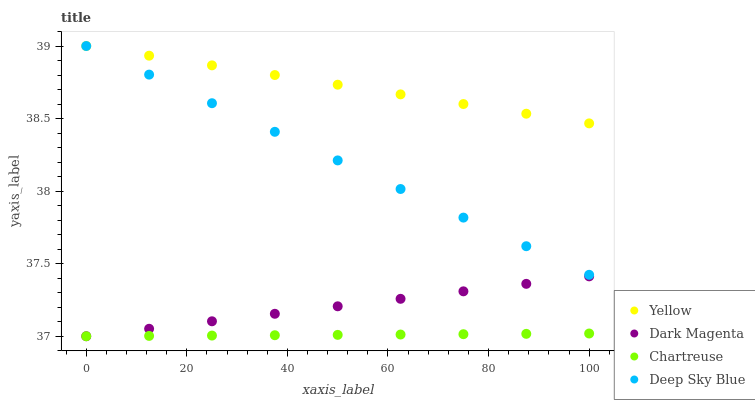Does Chartreuse have the minimum area under the curve?
Answer yes or no. Yes. Does Yellow have the maximum area under the curve?
Answer yes or no. Yes. Does Dark Magenta have the minimum area under the curve?
Answer yes or no. No. Does Dark Magenta have the maximum area under the curve?
Answer yes or no. No. Is Dark Magenta the smoothest?
Answer yes or no. Yes. Is Yellow the roughest?
Answer yes or no. Yes. Is Chartreuse the smoothest?
Answer yes or no. No. Is Chartreuse the roughest?
Answer yes or no. No. Does Chartreuse have the lowest value?
Answer yes or no. Yes. Does Yellow have the lowest value?
Answer yes or no. No. Does Yellow have the highest value?
Answer yes or no. Yes. Does Dark Magenta have the highest value?
Answer yes or no. No. Is Chartreuse less than Deep Sky Blue?
Answer yes or no. Yes. Is Deep Sky Blue greater than Dark Magenta?
Answer yes or no. Yes. Does Yellow intersect Deep Sky Blue?
Answer yes or no. Yes. Is Yellow less than Deep Sky Blue?
Answer yes or no. No. Is Yellow greater than Deep Sky Blue?
Answer yes or no. No. Does Chartreuse intersect Deep Sky Blue?
Answer yes or no. No. 